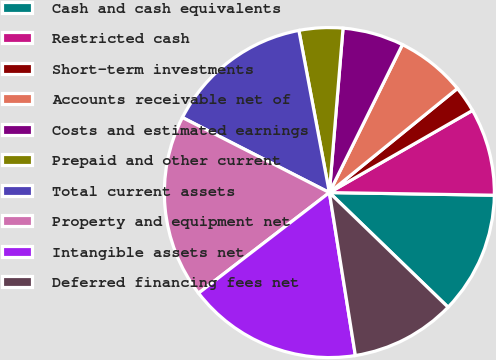Convert chart. <chart><loc_0><loc_0><loc_500><loc_500><pie_chart><fcel>Cash and cash equivalents<fcel>Restricted cash<fcel>Short-term investments<fcel>Accounts receivable net of<fcel>Costs and estimated earnings<fcel>Prepaid and other current<fcel>Total current assets<fcel>Property and equipment net<fcel>Intangible assets net<fcel>Deferred financing fees net<nl><fcel>11.97%<fcel>8.55%<fcel>2.57%<fcel>6.84%<fcel>5.98%<fcel>4.28%<fcel>14.53%<fcel>17.95%<fcel>17.09%<fcel>10.26%<nl></chart> 